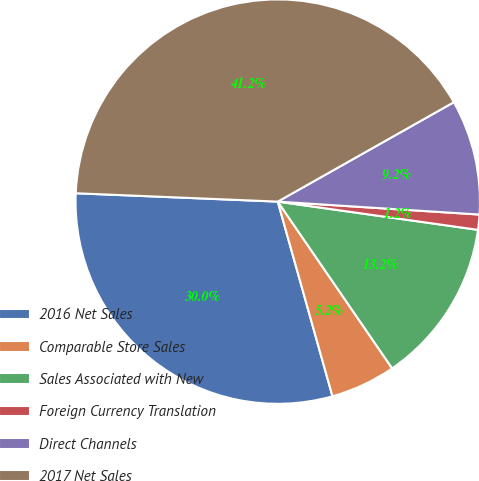<chart> <loc_0><loc_0><loc_500><loc_500><pie_chart><fcel>2016 Net Sales<fcel>Comparable Store Sales<fcel>Sales Associated with New<fcel>Foreign Currency Translation<fcel>Direct Channels<fcel>2017 Net Sales<nl><fcel>30.02%<fcel>5.21%<fcel>13.2%<fcel>1.21%<fcel>9.2%<fcel>41.16%<nl></chart> 